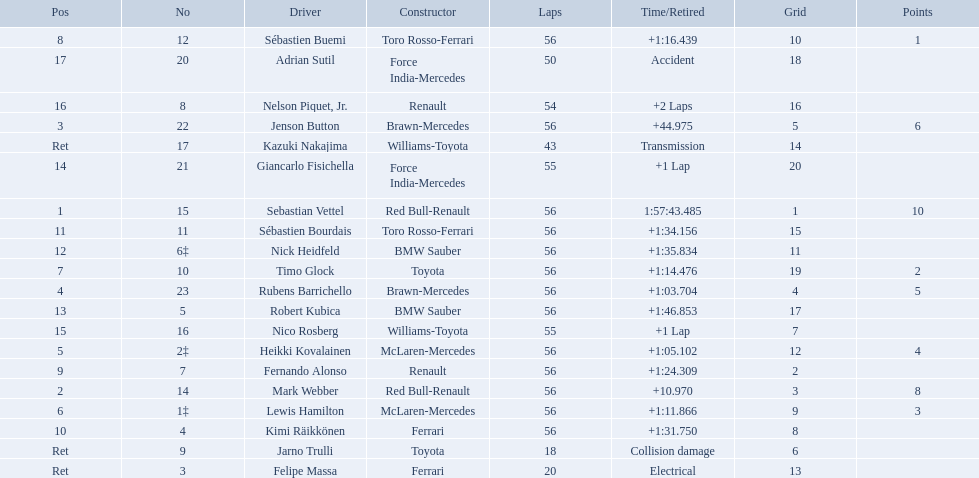Who were all of the drivers in the 2009 chinese grand prix? Sebastian Vettel, Mark Webber, Jenson Button, Rubens Barrichello, Heikki Kovalainen, Lewis Hamilton, Timo Glock, Sébastien Buemi, Fernando Alonso, Kimi Räikkönen, Sébastien Bourdais, Nick Heidfeld, Robert Kubica, Giancarlo Fisichella, Nico Rosberg, Nelson Piquet, Jr., Adrian Sutil, Kazuki Nakajima, Felipe Massa, Jarno Trulli. And what were their finishing times? 1:57:43.485, +10.970, +44.975, +1:03.704, +1:05.102, +1:11.866, +1:14.476, +1:16.439, +1:24.309, +1:31.750, +1:34.156, +1:35.834, +1:46.853, +1 Lap, +1 Lap, +2 Laps, Accident, Transmission, Electrical, Collision damage. Which player faced collision damage and retired from the race? Jarno Trulli. Who are all of the drivers? Sebastian Vettel, Mark Webber, Jenson Button, Rubens Barrichello, Heikki Kovalainen, Lewis Hamilton, Timo Glock, Sébastien Buemi, Fernando Alonso, Kimi Räikkönen, Sébastien Bourdais, Nick Heidfeld, Robert Kubica, Giancarlo Fisichella, Nico Rosberg, Nelson Piquet, Jr., Adrian Sutil, Kazuki Nakajima, Felipe Massa, Jarno Trulli. Who were their constructors? Red Bull-Renault, Red Bull-Renault, Brawn-Mercedes, Brawn-Mercedes, McLaren-Mercedes, McLaren-Mercedes, Toyota, Toro Rosso-Ferrari, Renault, Ferrari, Toro Rosso-Ferrari, BMW Sauber, BMW Sauber, Force India-Mercedes, Williams-Toyota, Renault, Force India-Mercedes, Williams-Toyota, Ferrari, Toyota. Who was the first listed driver to not drive a ferrari?? Sebastian Vettel. 